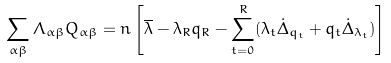Convert formula to latex. <formula><loc_0><loc_0><loc_500><loc_500>\sum _ { \alpha \beta } \Lambda _ { \alpha \beta } Q _ { \alpha \beta } = n \left [ \overline { \lambda } - \lambda _ { R } q _ { R } - \sum _ { t = 0 } ^ { R } ( \lambda _ { t } \dot { \Delta } _ { q _ { t } } + q _ { t } \dot { \Delta } _ { \lambda _ { t } } ) \right ]</formula> 